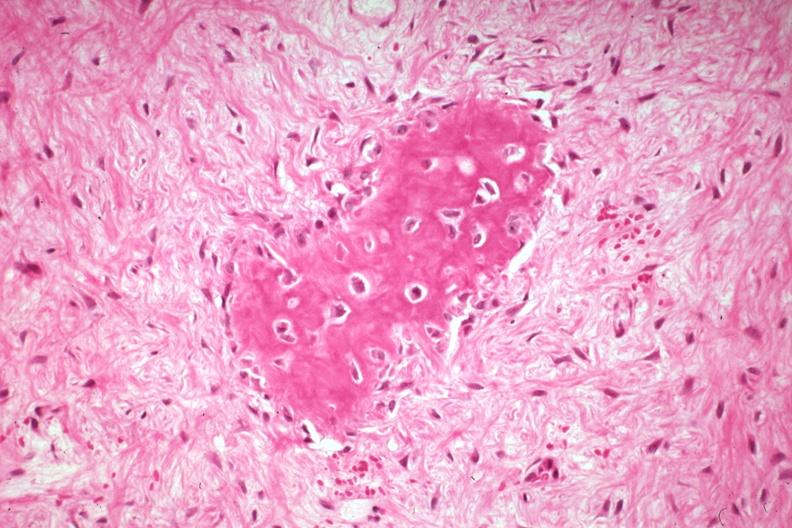s joints present?
Answer the question using a single word or phrase. Yes 